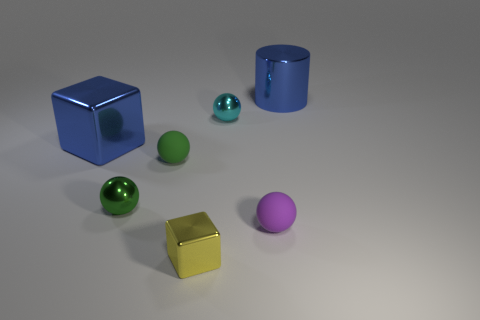What is the color of the thing that is both on the right side of the tiny cyan object and behind the tiny green metallic thing? The object you're referring to appears to be a purple ball. 